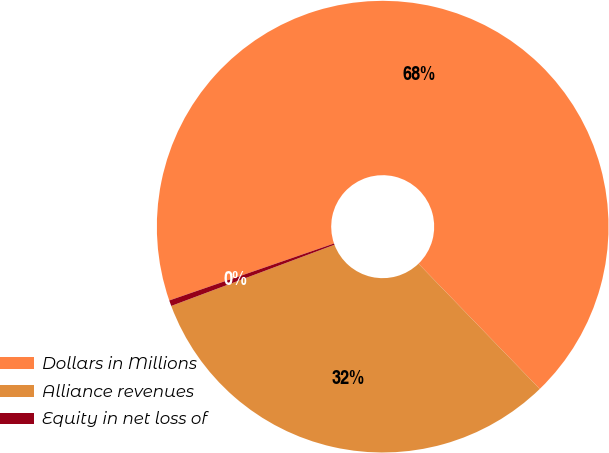Convert chart to OTSL. <chart><loc_0><loc_0><loc_500><loc_500><pie_chart><fcel>Dollars in Millions<fcel>Alliance revenues<fcel>Equity in net loss of<nl><fcel>68.06%<fcel>31.53%<fcel>0.41%<nl></chart> 